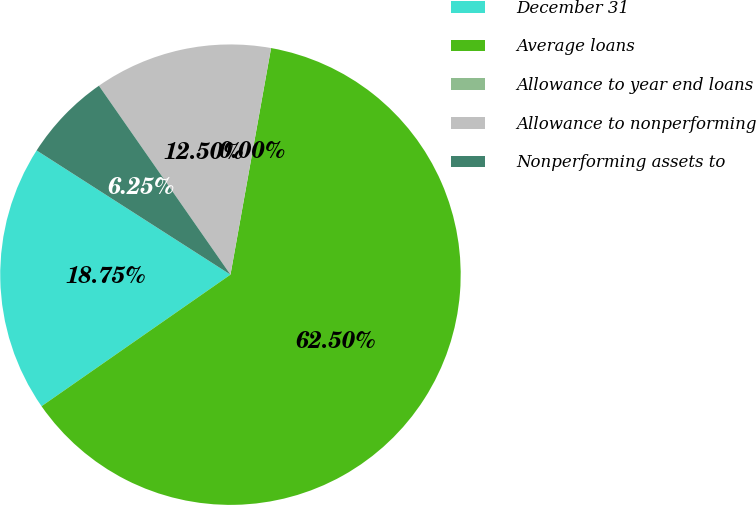<chart> <loc_0><loc_0><loc_500><loc_500><pie_chart><fcel>December 31<fcel>Average loans<fcel>Allowance to year end loans<fcel>Allowance to nonperforming<fcel>Nonperforming assets to<nl><fcel>18.75%<fcel>62.49%<fcel>0.0%<fcel>12.5%<fcel>6.25%<nl></chart> 